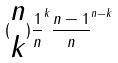Convert formula to latex. <formula><loc_0><loc_0><loc_500><loc_500>( \begin{matrix} n \\ k \end{matrix} ) \frac { 1 } { n } ^ { k } \frac { n - 1 } { n } ^ { n - k }</formula> 